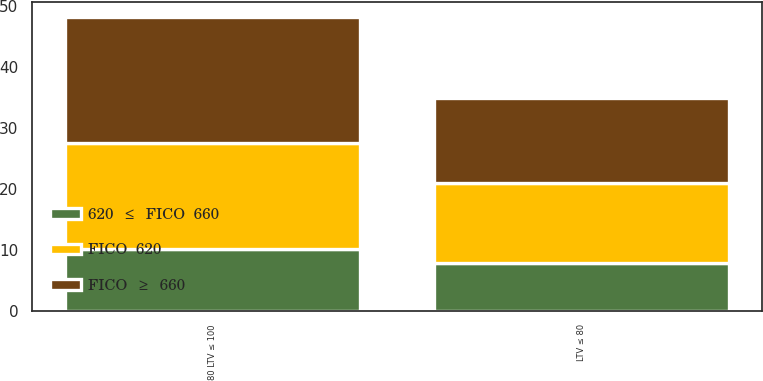<chart> <loc_0><loc_0><loc_500><loc_500><stacked_bar_chart><ecel><fcel>LTV ≤ 80<fcel>80 LTV ≤ 100<nl><fcel>620  ≤  FICO  660<fcel>7.9<fcel>10.2<nl><fcel>FICO  620<fcel>13.1<fcel>17.3<nl><fcel>FICO  ≥  660<fcel>14<fcel>20.7<nl></chart> 